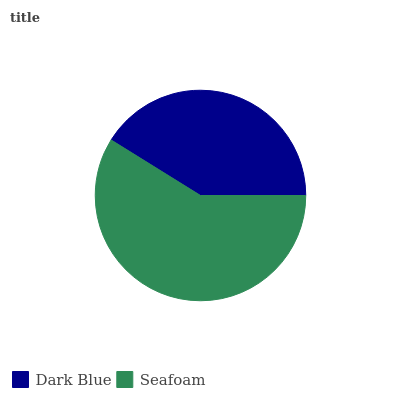Is Dark Blue the minimum?
Answer yes or no. Yes. Is Seafoam the maximum?
Answer yes or no. Yes. Is Seafoam the minimum?
Answer yes or no. No. Is Seafoam greater than Dark Blue?
Answer yes or no. Yes. Is Dark Blue less than Seafoam?
Answer yes or no. Yes. Is Dark Blue greater than Seafoam?
Answer yes or no. No. Is Seafoam less than Dark Blue?
Answer yes or no. No. Is Seafoam the high median?
Answer yes or no. Yes. Is Dark Blue the low median?
Answer yes or no. Yes. Is Dark Blue the high median?
Answer yes or no. No. Is Seafoam the low median?
Answer yes or no. No. 